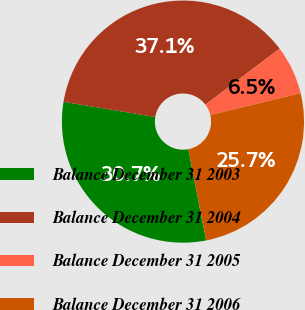<chart> <loc_0><loc_0><loc_500><loc_500><pie_chart><fcel>Balance December 31 2003<fcel>Balance December 31 2004<fcel>Balance December 31 2005<fcel>Balance December 31 2006<nl><fcel>30.68%<fcel>37.09%<fcel>6.53%<fcel>25.7%<nl></chart> 